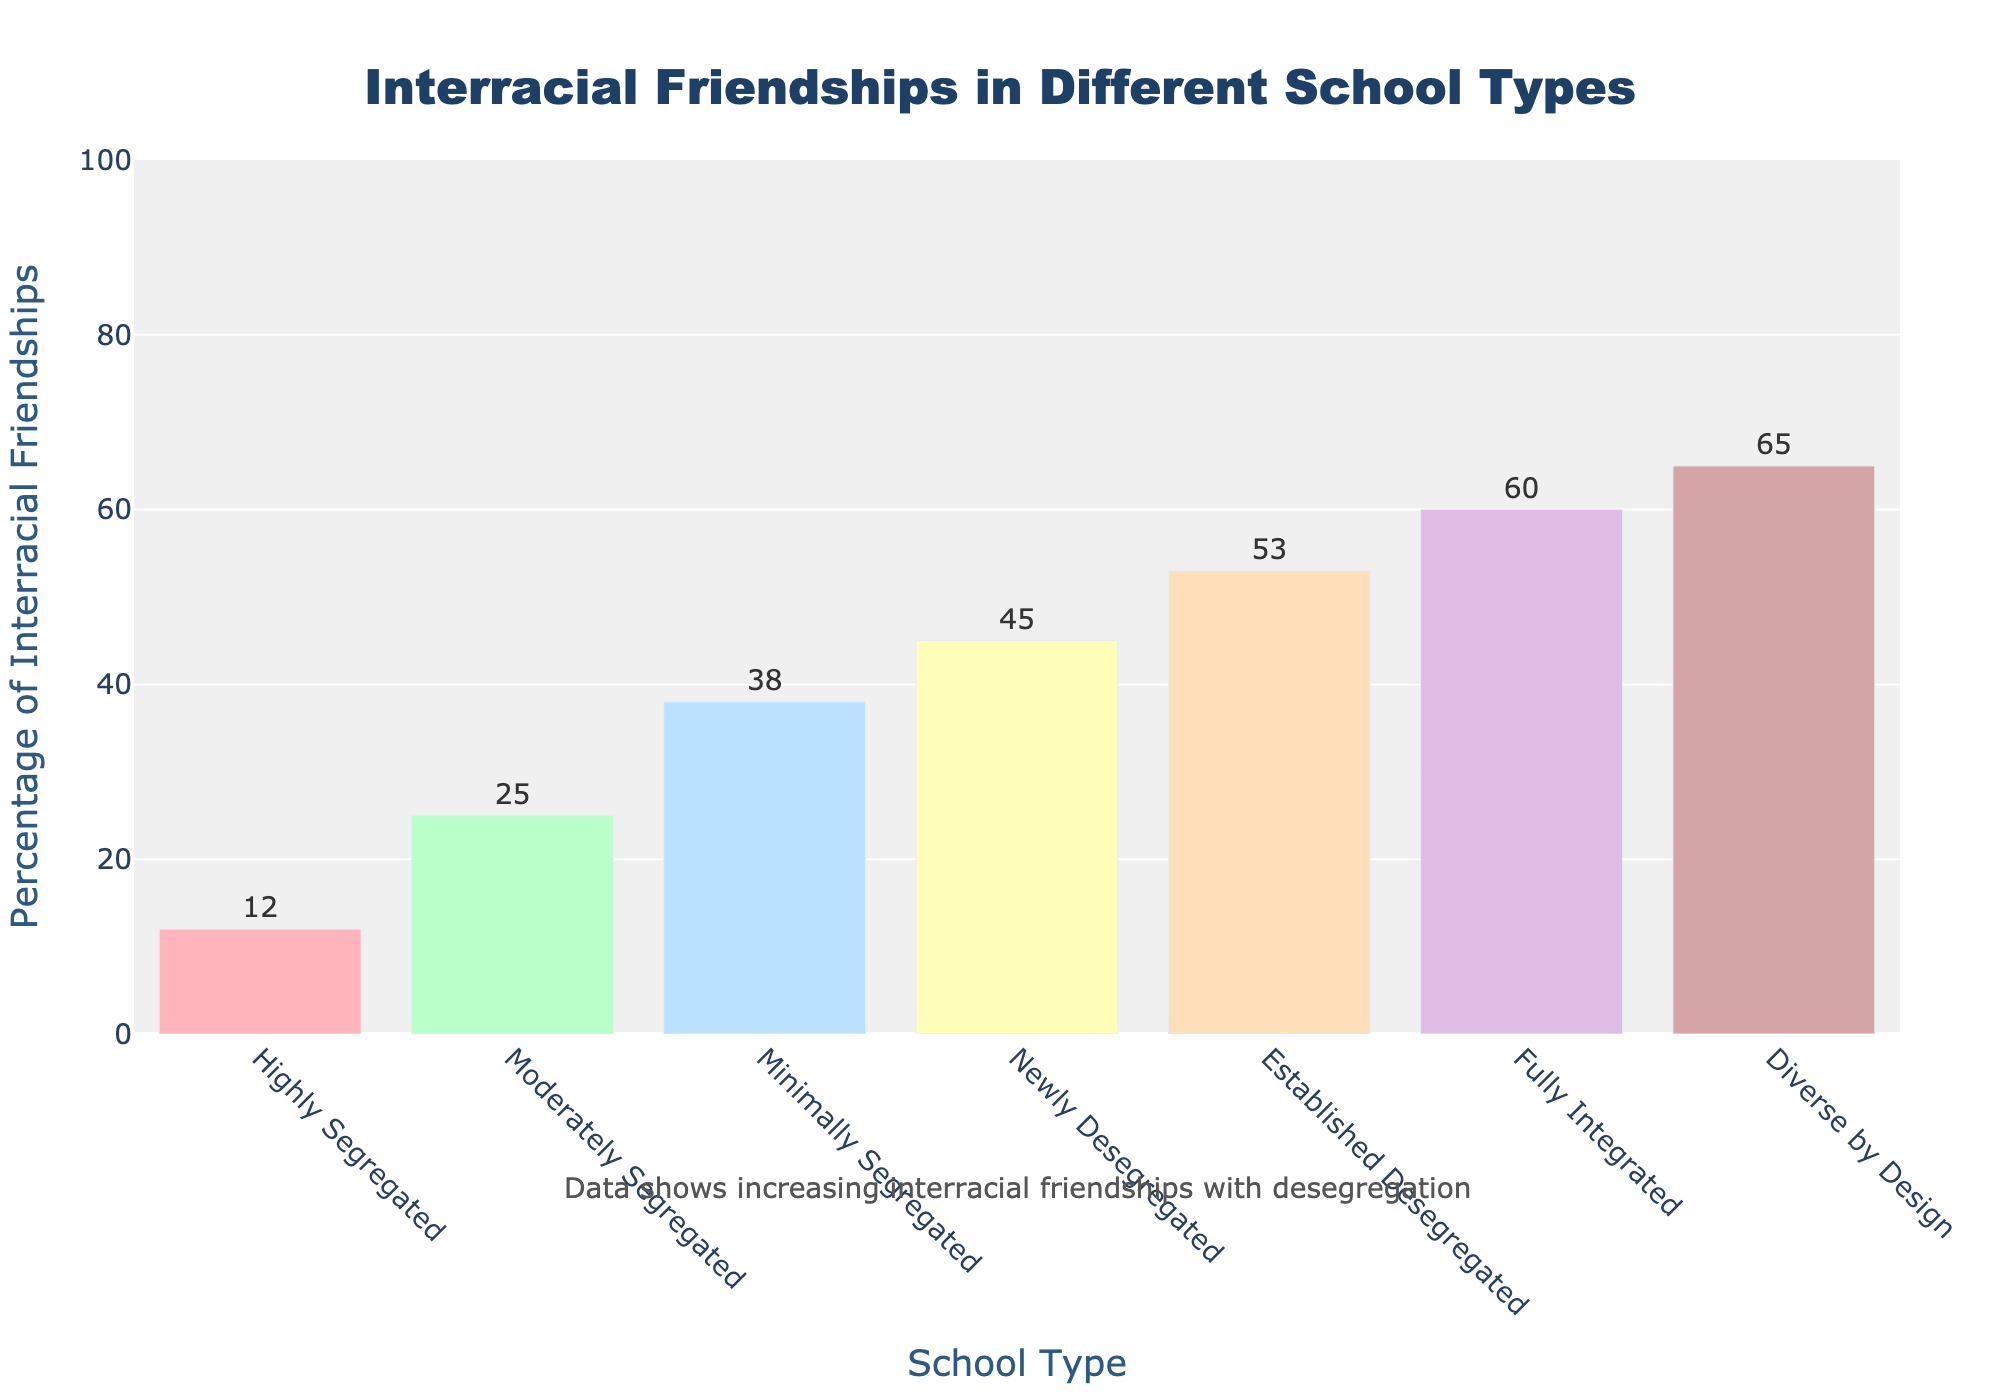What percentage of interracial friendships exist in fully integrated schools? The bar for Fully Integrated schools reaches up to the 60% mark.
Answer: 60% How does the percentage of interracial friendships in established desegregated schools compare to newly desegregated schools? For newly desegregated schools, the percentage is 45%, while for established desegregated schools, it is 53%. Subtracting these values gives an 8% higher rate in established desegregated schools.
Answer: 8% higher Which school type has the lowest percentage of interracial friendships? The bar for Highly Segregated schools has the smallest height at 12%.
Answer: Highly Segregated What is the difference in the percentage of interracial friendships between moderately segregated and diverse by design schools? The percentage for Moderately Segregated schools is 25%, and for Diverse by Design schools, it is 65%. Subtracting them gives a difference of 40%.
Answer: 40% What is the average percentage of interracial friendships across all school types? Sum the percentages (12 + 25 + 38 + 45 + 53 + 60 + 65 = 298) and divide by the number of school types (7): 298/7 = 42.57.
Answer: 42.57% In which school type is the increase in percentage of interracial friendships the highest compared to the next less integrated category? The increase from Minimally Segregated (38%) to Newly Desegregated (45%) is the highest at 7%.
Answer: Minimally Segregated to Newly Desegregated Which two school types have the most similar percentages of interracial friendships? Comparing the bars, “Newly Desegregated” has 45% and “Established Desegregated” has 53%. The difference is 8%, which is the smallest difference noted.
Answer: Newly Desegregated and Established Desegregated How does the color of the bar visually distinguish between highly segregated and diverse by design schools? The bar for Highly Segregated schools is visually lighter and different in color compared to the darker and different color for Diverse by Design schools.
Answer: Lighter and different What is the sum of the percentages for all desegregated school types? Adding percentages: Newly Desegregated (45) + Established Desegregated (53) + Fully Integrated (60) + Diverse by Design (65): 45 + 53 + 60 + 65 = 223.
Answer: 223% By how much does the percentage of interracial friendships increase from highly segregated to minimally segregated schools? Subtracting Highly Segregated (12%) from Minimally Segregated (38%): 38 - 12 = 26%.
Answer: 26% 